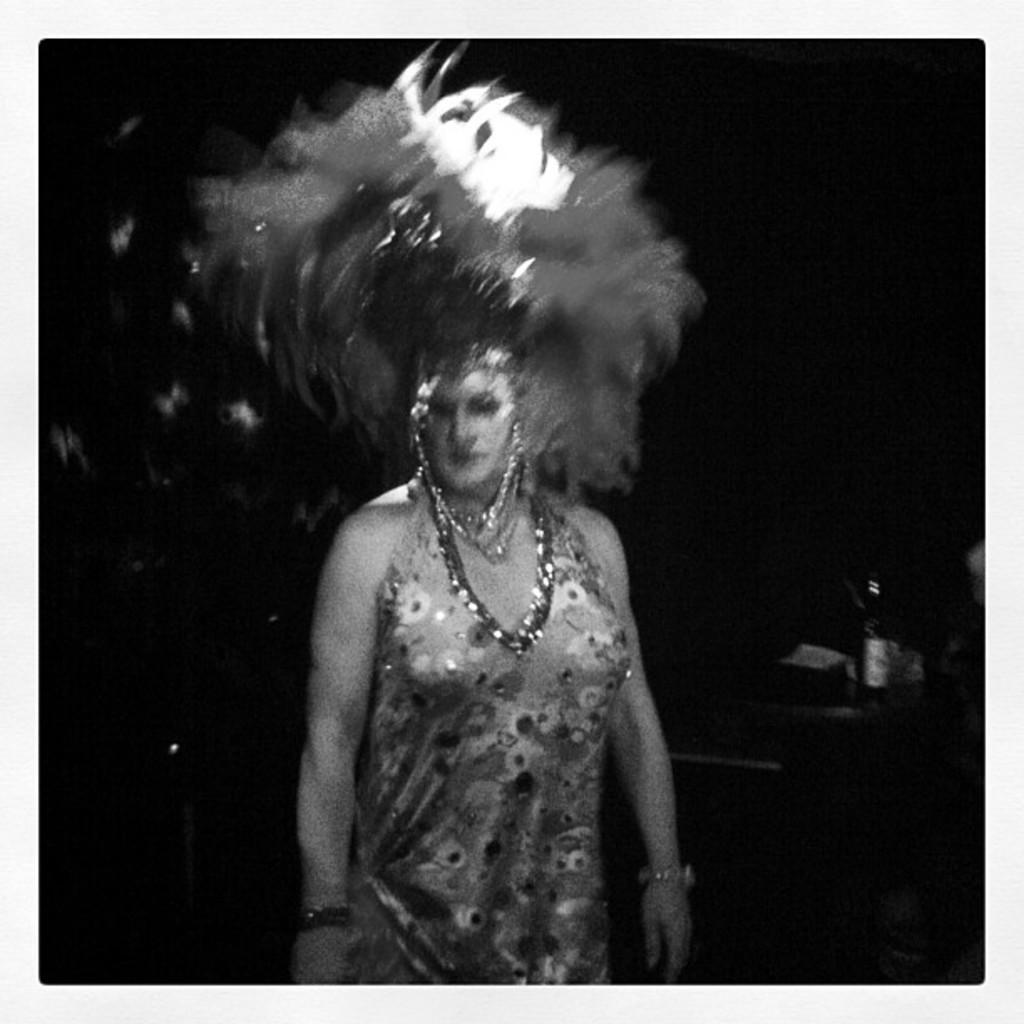Describe this image in one or two sentences. In this picture we can see a woman is standing, on the right side there is a bottle, we can see a dark background, it is a black and white image. 